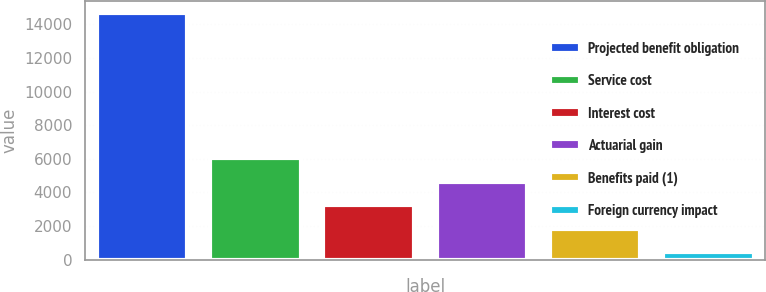Convert chart. <chart><loc_0><loc_0><loc_500><loc_500><bar_chart><fcel>Projected benefit obligation<fcel>Service cost<fcel>Interest cost<fcel>Actuarial gain<fcel>Benefits paid (1)<fcel>Foreign currency impact<nl><fcel>14675.7<fcel>6019.8<fcel>3240.4<fcel>4630.1<fcel>1850.7<fcel>461<nl></chart> 